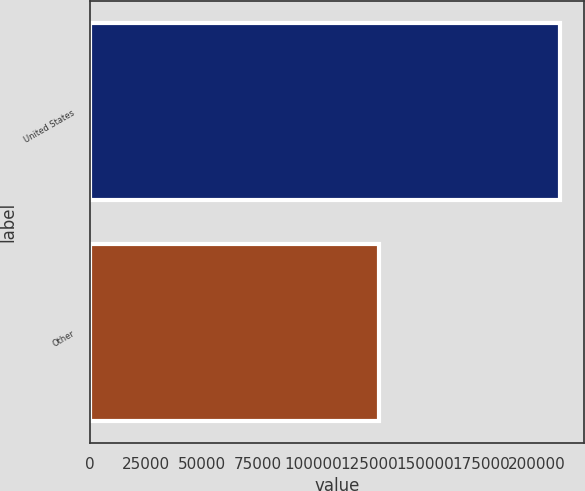Convert chart. <chart><loc_0><loc_0><loc_500><loc_500><bar_chart><fcel>United States<fcel>Other<nl><fcel>210559<fcel>129209<nl></chart> 